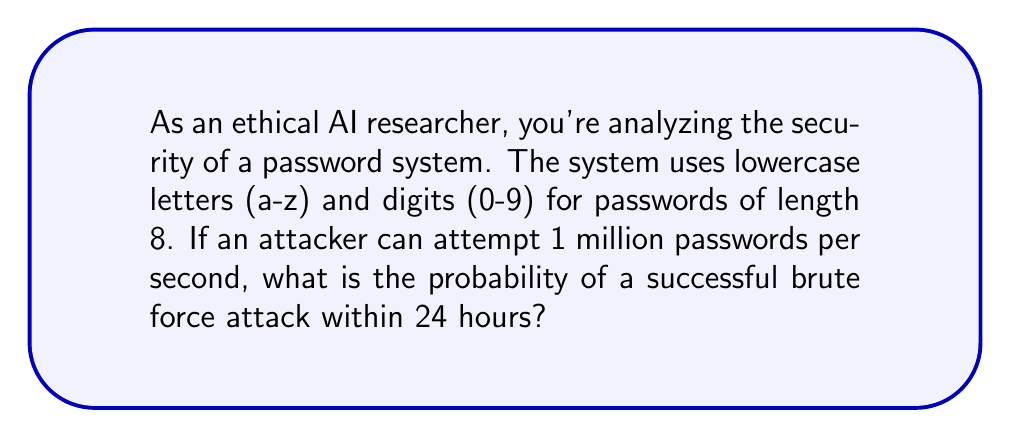Solve this math problem. Let's approach this step-by-step:

1) First, calculate the total number of possible passwords:
   - There are 26 lowercase letters and 10 digits, so 36 characters in total.
   - The password length is 8.
   - Total combinations: $36^8 = 2,821,109,907,456$

2) Calculate how many attempts can be made in 24 hours:
   - 1 million attempts per second
   - Seconds in 24 hours: $24 * 60 * 60 = 86,400$
   - Total attempts: $86,400 * 1,000,000 = 86,400,000,000$

3) The probability of success is the number of attempts divided by the total number of possible passwords:

   $$P(\text{success}) = \frac{\text{Number of attempts}}{\text{Total possible passwords}}$$

   $$P(\text{success}) = \frac{86,400,000,000}{2,821,109,907,456}$$

4) Simplify the fraction:

   $$P(\text{success}) \approx 0.0306$$

5) Convert to a percentage:

   $$P(\text{success}) \approx 3.06\%$$
Answer: $3.06\%$ 